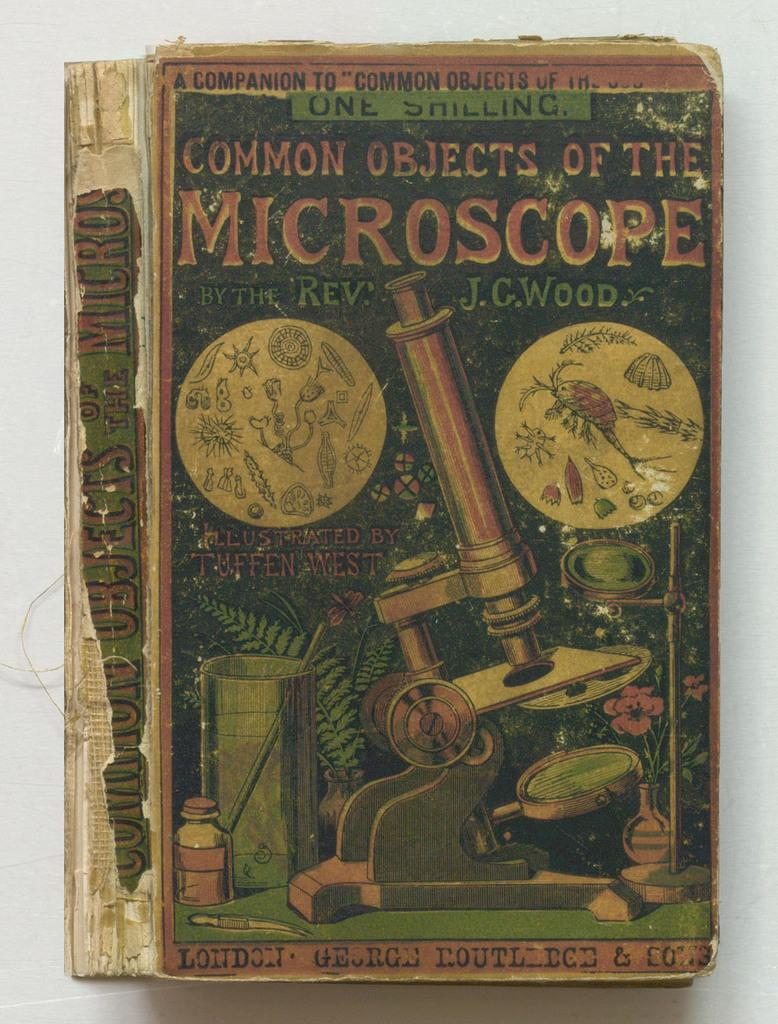<image>
Relay a brief, clear account of the picture shown. A very old book with the title COMMON OBJECTS OF THE MICROSCOPE. 